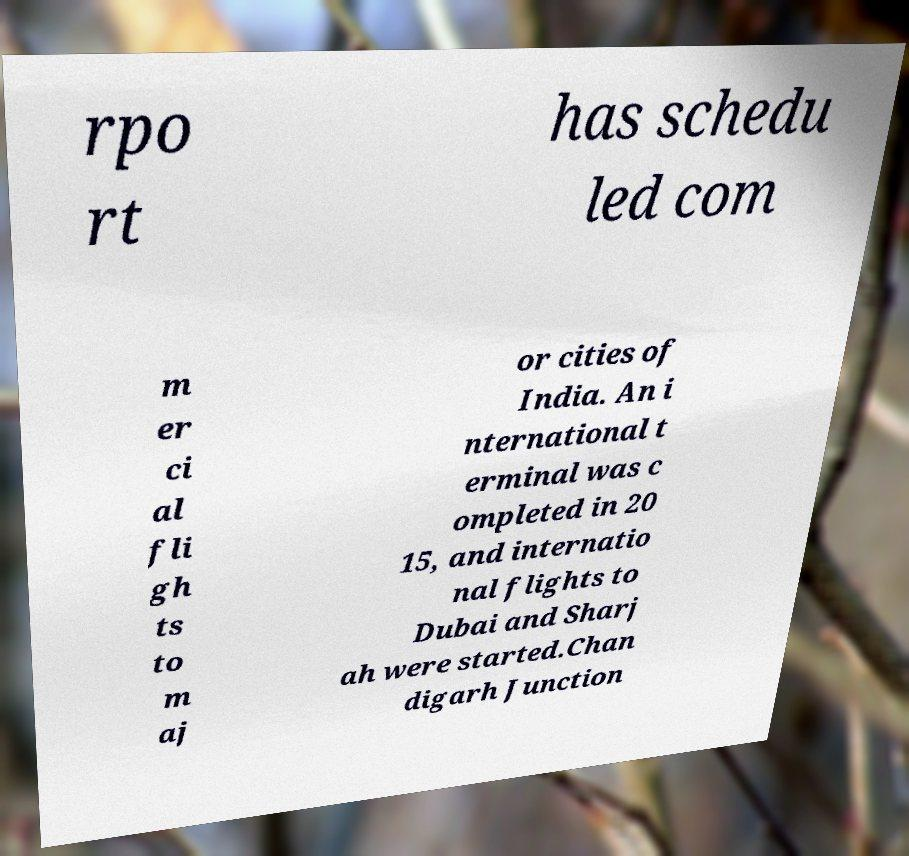Can you accurately transcribe the text from the provided image for me? rpo rt has schedu led com m er ci al fli gh ts to m aj or cities of India. An i nternational t erminal was c ompleted in 20 15, and internatio nal flights to Dubai and Sharj ah were started.Chan digarh Junction 